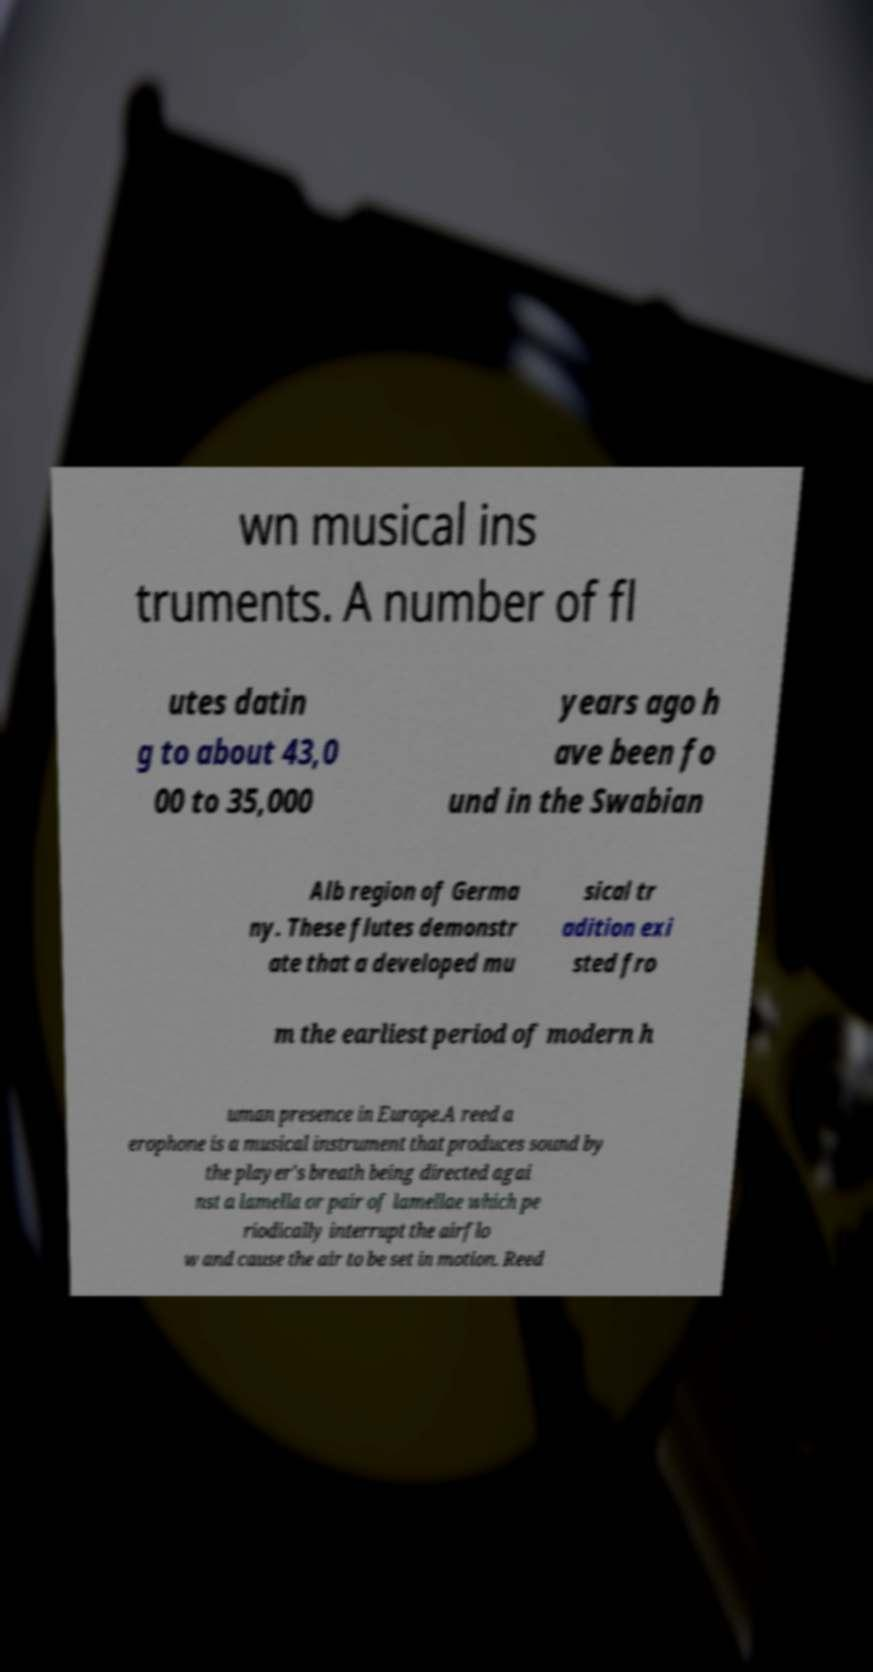There's text embedded in this image that I need extracted. Can you transcribe it verbatim? wn musical ins truments. A number of fl utes datin g to about 43,0 00 to 35,000 years ago h ave been fo und in the Swabian Alb region of Germa ny. These flutes demonstr ate that a developed mu sical tr adition exi sted fro m the earliest period of modern h uman presence in Europe.A reed a erophone is a musical instrument that produces sound by the player's breath being directed agai nst a lamella or pair of lamellae which pe riodically interrupt the airflo w and cause the air to be set in motion. Reed 